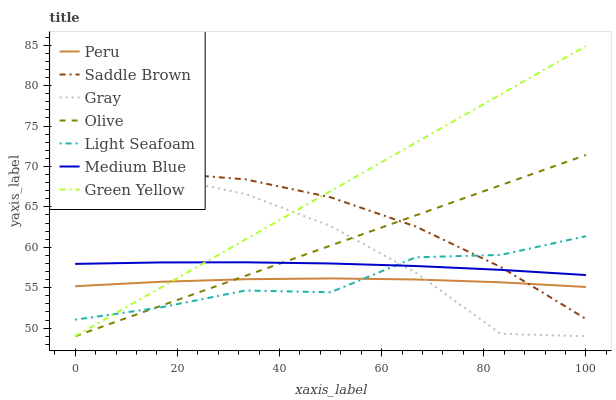Does Peru have the minimum area under the curve?
Answer yes or no. Yes. Does Green Yellow have the maximum area under the curve?
Answer yes or no. Yes. Does Medium Blue have the minimum area under the curve?
Answer yes or no. No. Does Medium Blue have the maximum area under the curve?
Answer yes or no. No. Is Olive the smoothest?
Answer yes or no. Yes. Is Gray the roughest?
Answer yes or no. Yes. Is Green Yellow the smoothest?
Answer yes or no. No. Is Green Yellow the roughest?
Answer yes or no. No. Does Gray have the lowest value?
Answer yes or no. Yes. Does Medium Blue have the lowest value?
Answer yes or no. No. Does Green Yellow have the highest value?
Answer yes or no. Yes. Does Medium Blue have the highest value?
Answer yes or no. No. Is Peru less than Medium Blue?
Answer yes or no. Yes. Is Medium Blue greater than Peru?
Answer yes or no. Yes. Does Green Yellow intersect Saddle Brown?
Answer yes or no. Yes. Is Green Yellow less than Saddle Brown?
Answer yes or no. No. Is Green Yellow greater than Saddle Brown?
Answer yes or no. No. Does Peru intersect Medium Blue?
Answer yes or no. No. 